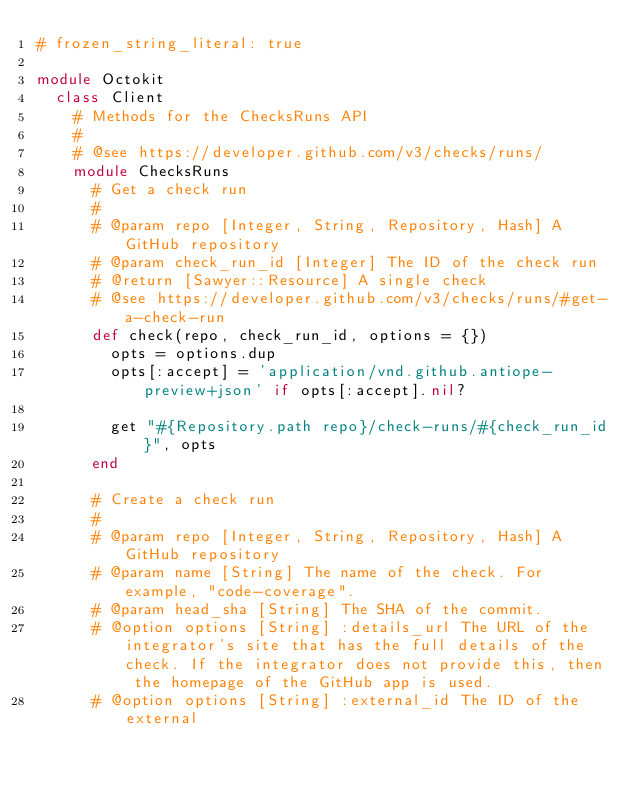Convert code to text. <code><loc_0><loc_0><loc_500><loc_500><_Ruby_># frozen_string_literal: true

module Octokit
  class Client
    # Methods for the ChecksRuns API
    #
    # @see https://developer.github.com/v3/checks/runs/
    module ChecksRuns
      # Get a check run
      #
      # @param repo [Integer, String, Repository, Hash] A GitHub repository
      # @param check_run_id [Integer] The ID of the check run
      # @return [Sawyer::Resource] A single check
      # @see https://developer.github.com/v3/checks/runs/#get-a-check-run
      def check(repo, check_run_id, options = {})
        opts = options.dup
        opts[:accept] = 'application/vnd.github.antiope-preview+json' if opts[:accept].nil?

        get "#{Repository.path repo}/check-runs/#{check_run_id}", opts
      end

      # Create a check run
      #
      # @param repo [Integer, String, Repository, Hash] A GitHub repository
      # @param name [String] The name of the check. For example, "code-coverage".
      # @param head_sha [String] The SHA of the commit.
      # @option options [String] :details_url The URL of the integrator's site that has the full details of the check. If the integrator does not provide this, then the homepage of the GitHub app is used.
      # @option options [String] :external_id The ID of the external</code> 